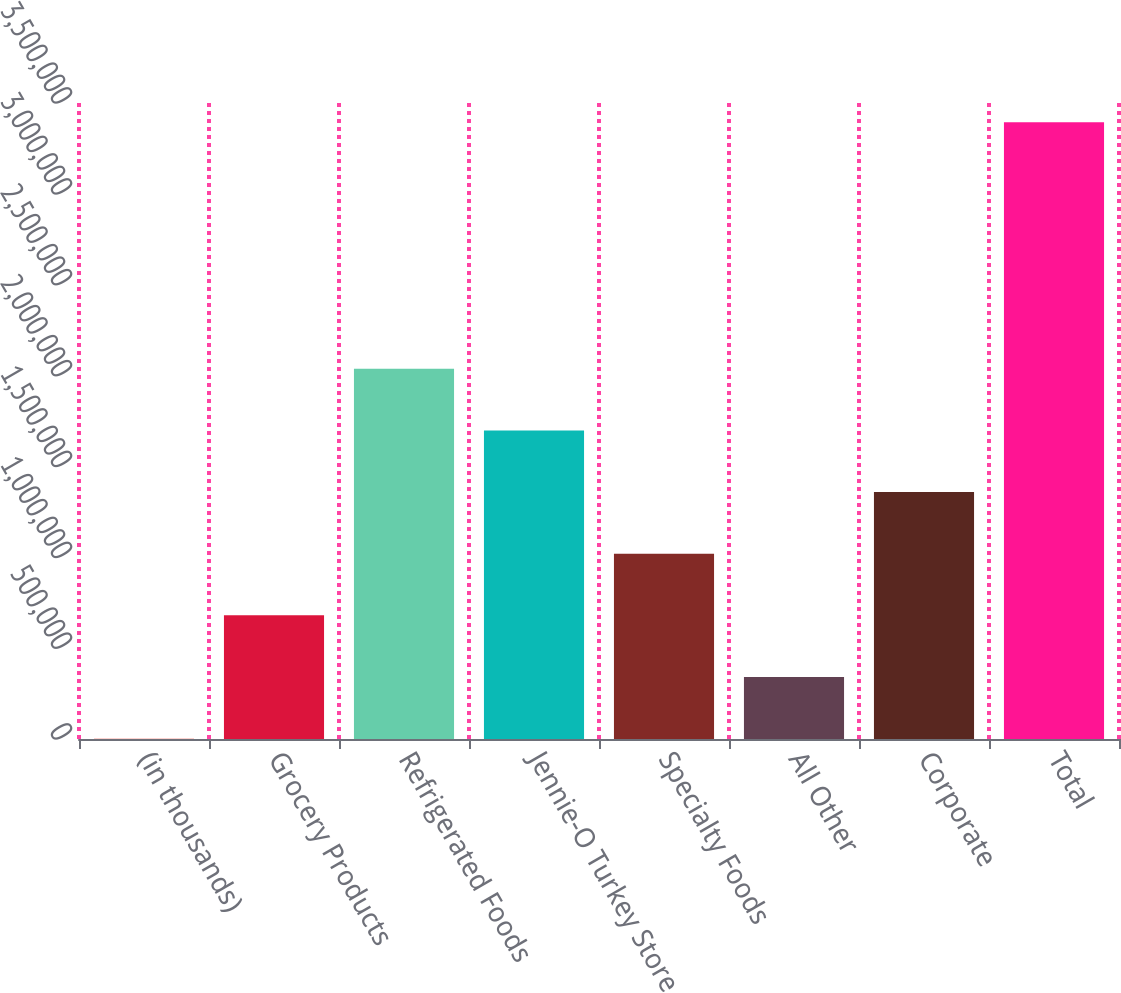<chart> <loc_0><loc_0><loc_500><loc_500><bar_chart><fcel>(in thousands)<fcel>Grocery Products<fcel>Refrigerated Foods<fcel>Jennie-O Turkey Store<fcel>Specialty Foods<fcel>All Other<fcel>Corporate<fcel>Total<nl><fcel>2007<fcel>680336<fcel>2.03699e+06<fcel>1.69783e+06<fcel>1.0195e+06<fcel>341171<fcel>1.35866e+06<fcel>3.39365e+06<nl></chart> 